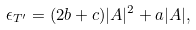Convert formula to latex. <formula><loc_0><loc_0><loc_500><loc_500>\epsilon _ { T ^ { \prime } } = ( 2 b + c ) | A | ^ { 2 } + a | A | ,</formula> 